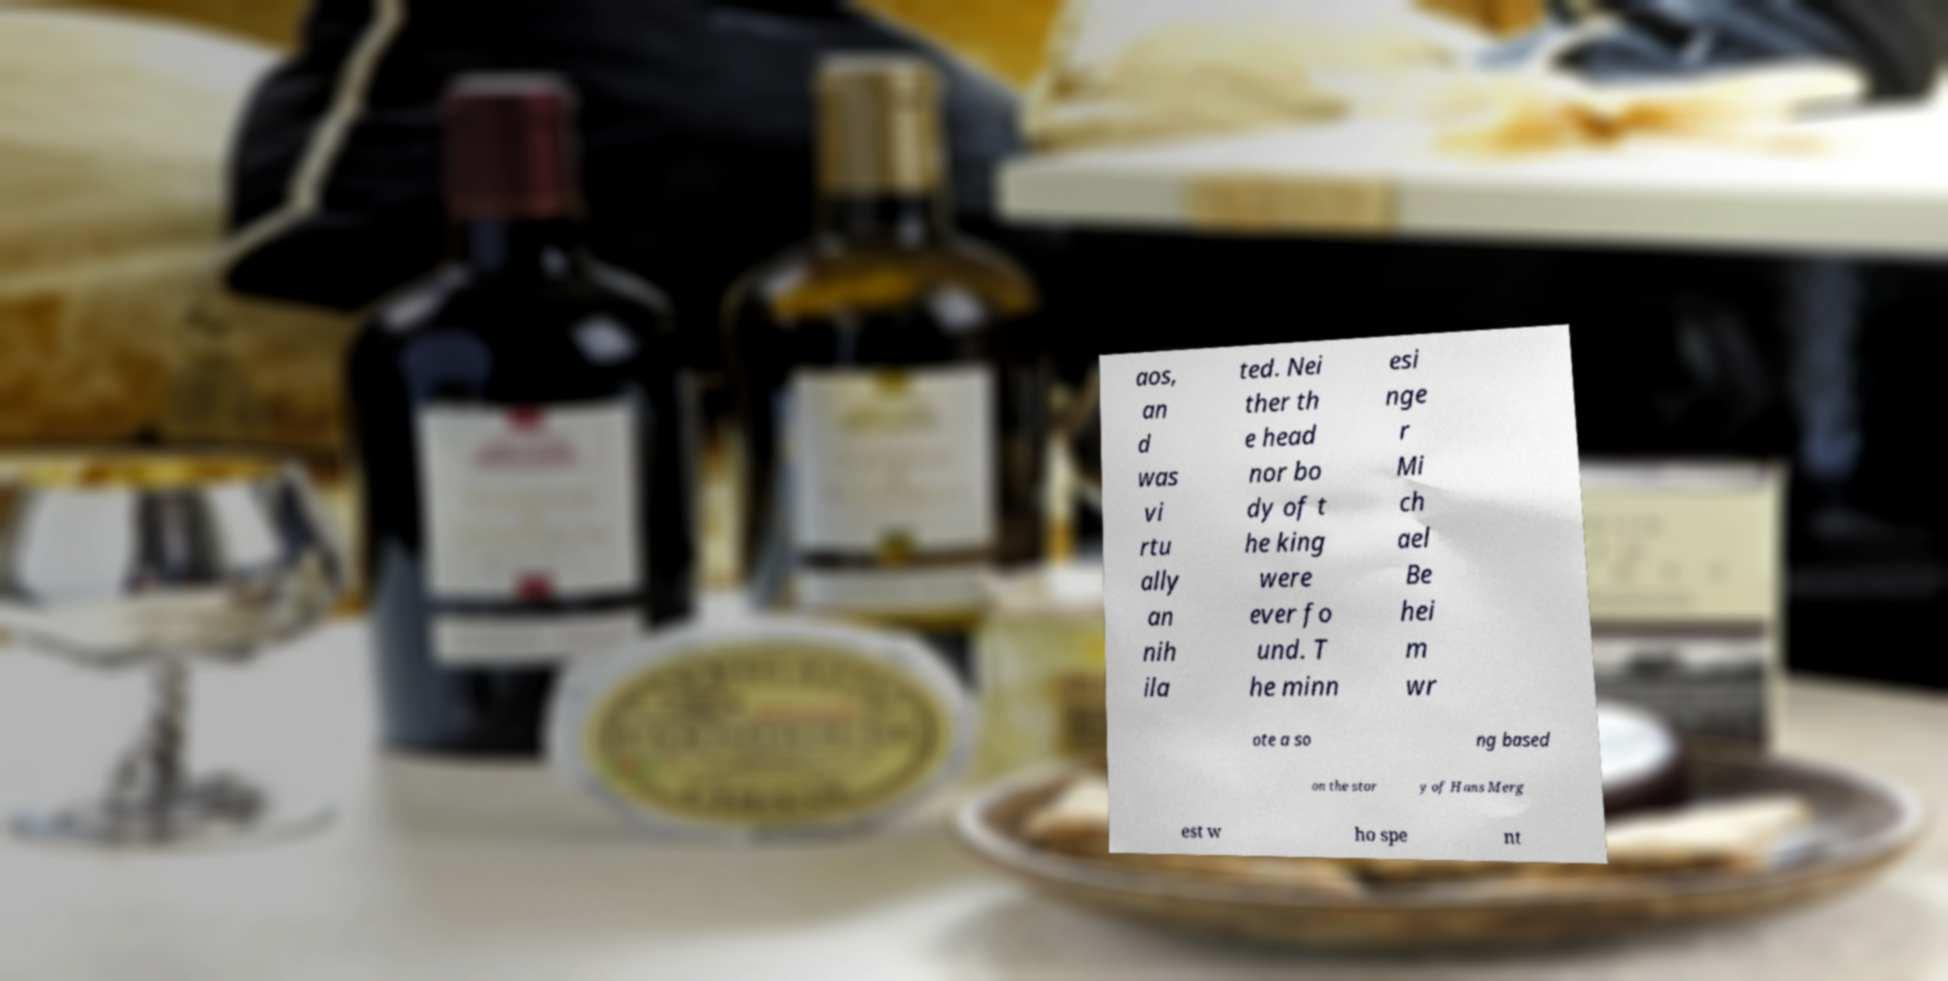Please identify and transcribe the text found in this image. aos, an d was vi rtu ally an nih ila ted. Nei ther th e head nor bo dy of t he king were ever fo und. T he minn esi nge r Mi ch ael Be hei m wr ote a so ng based on the stor y of Hans Merg est w ho spe nt 